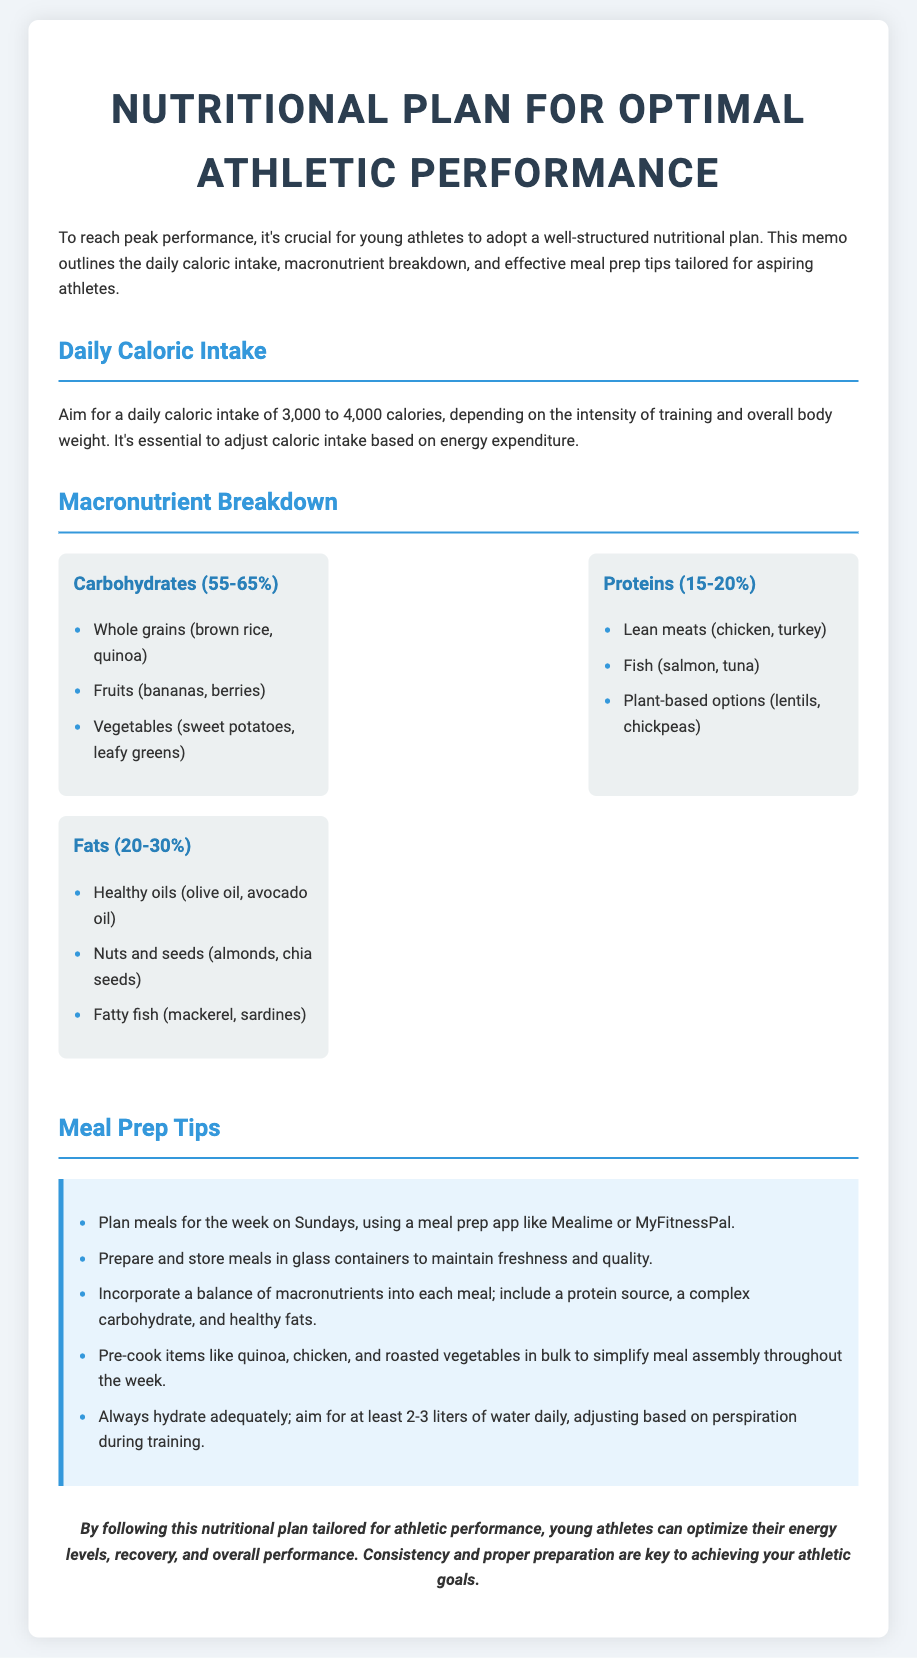what is the recommended daily caloric intake? The document states that young athletes should aim for a daily caloric intake of 3,000 to 4,000 calories.
Answer: 3,000 to 4,000 calories what percentage of macronutrients should come from carbohydrates? According to the memo, carbohydrates should make up 55-65% of the daily intake.
Answer: 55-65% name one healthy fat source mentioned in the document. The document lists several fatty sources, including healthy oils, nuts, and seeds. One example is olive oil.
Answer: olive oil how many liters of water should athletes aim to hydrate daily? The memo recommends young athletes aim for at least 2-3 liters of water daily.
Answer: 2-3 liters what is one meal prep tip provided in the document? The document includes various meal prep tips; one is to plan meals for the week on Sundays.
Answer: plan meals for the week on Sundays what is the percentage range for protein intake? The document mentions that protein should comprise 15-20% of daily caloric intake.
Answer: 15-20% which meal prep app is suggested in the memo? The memo suggests using a meal prep app like Mealime or MyFitnessPal.
Answer: Mealime or MyFitnessPal what should each meal include according to the meal prep tips? The meal prep tips specify that each meal should include a protein source, a complex carbohydrate, and healthy fats.
Answer: protein source, complex carbohydrate, and healthy fats 